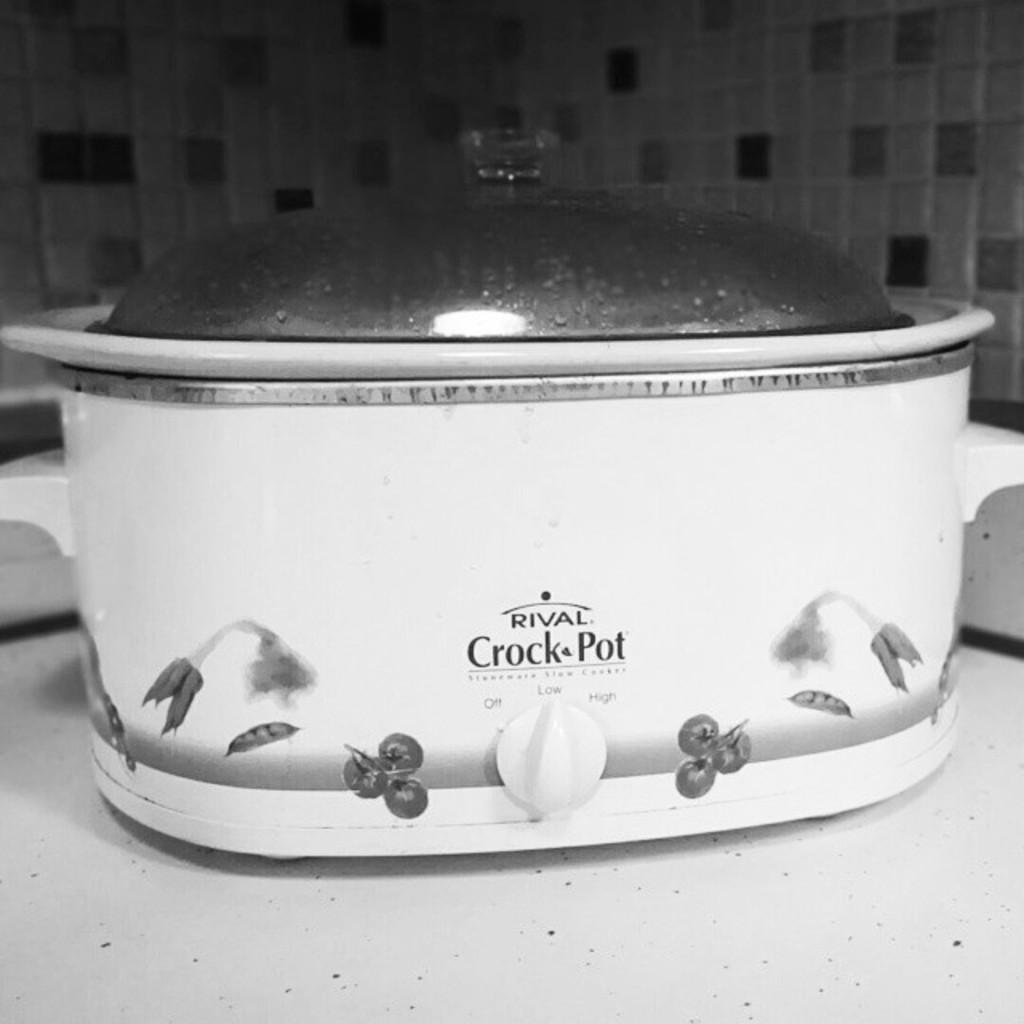<image>
Write a terse but informative summary of the picture. A Rival brand crock pot is set to the low cooking temperature. 